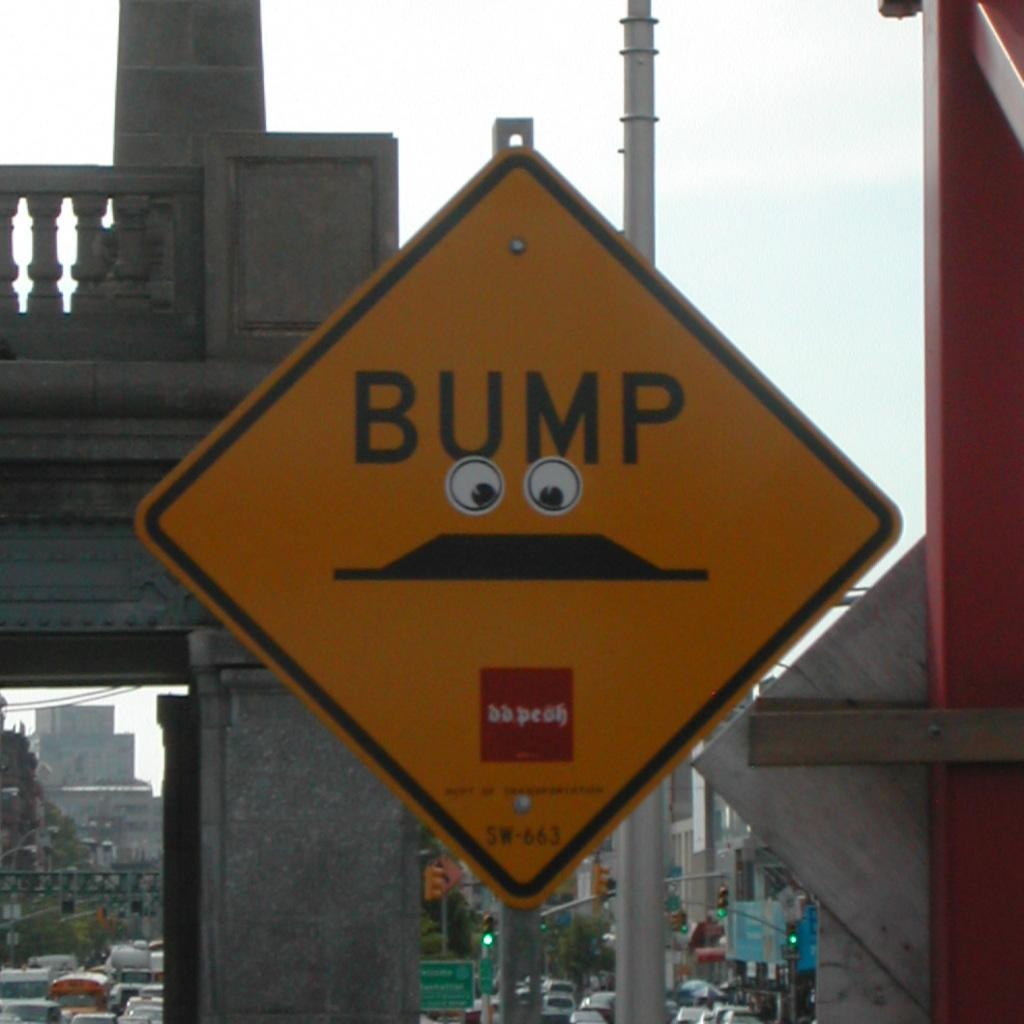Provide a one-sentence caption for the provided image. Someone has placed sticker eyes on a "Bump" road sign. 